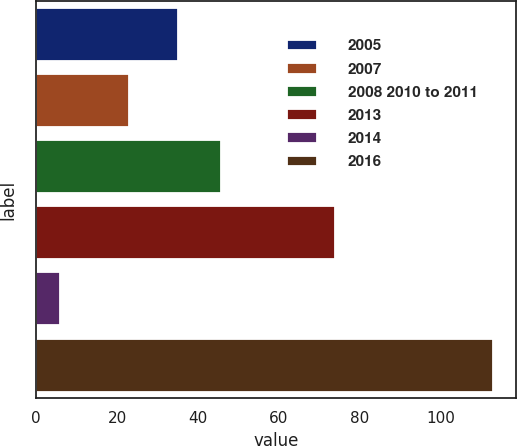Convert chart to OTSL. <chart><loc_0><loc_0><loc_500><loc_500><bar_chart><fcel>2005<fcel>2007<fcel>2008 2010 to 2011<fcel>2013<fcel>2014<fcel>2016<nl><fcel>35<fcel>23<fcel>45.7<fcel>74<fcel>6<fcel>113<nl></chart> 